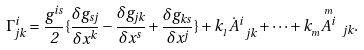Convert formula to latex. <formula><loc_0><loc_0><loc_500><loc_500>\Gamma ^ { i } _ { j k } = \frac { g ^ { i s } } { 2 } \{ \frac { \delta g _ { s j } } { \delta x ^ { k } } - \frac { \delta g _ { j k } } { \delta x ^ { s } } + \frac { \delta g _ { k s } } { \delta x ^ { j } } \} + k _ { _ { 1 } } \dot { A } ^ { i } _ { \ j k } + \cdots + k _ { _ { m } } \overset { _ { m } } { A ^ { i } } _ { \ j k } .</formula> 